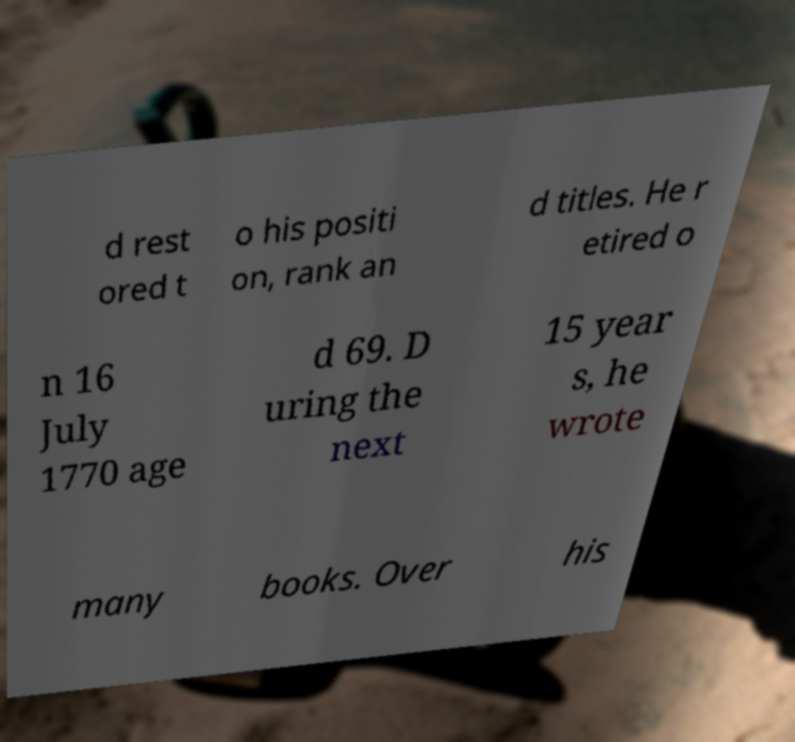Could you assist in decoding the text presented in this image and type it out clearly? d rest ored t o his positi on, rank an d titles. He r etired o n 16 July 1770 age d 69. D uring the next 15 year s, he wrote many books. Over his 